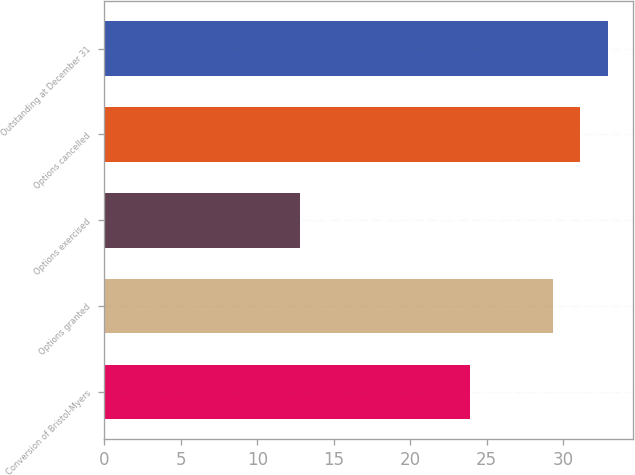<chart> <loc_0><loc_0><loc_500><loc_500><bar_chart><fcel>Conversion of Bristol-Myers<fcel>Options granted<fcel>Options exercised<fcel>Options cancelled<fcel>Outstanding at December 31<nl><fcel>23.93<fcel>29.33<fcel>12.8<fcel>31.13<fcel>32.93<nl></chart> 